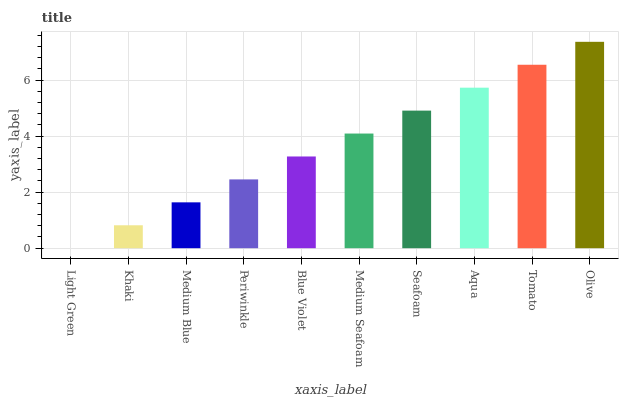Is Light Green the minimum?
Answer yes or no. Yes. Is Olive the maximum?
Answer yes or no. Yes. Is Khaki the minimum?
Answer yes or no. No. Is Khaki the maximum?
Answer yes or no. No. Is Khaki greater than Light Green?
Answer yes or no. Yes. Is Light Green less than Khaki?
Answer yes or no. Yes. Is Light Green greater than Khaki?
Answer yes or no. No. Is Khaki less than Light Green?
Answer yes or no. No. Is Medium Seafoam the high median?
Answer yes or no. Yes. Is Blue Violet the low median?
Answer yes or no. Yes. Is Khaki the high median?
Answer yes or no. No. Is Medium Blue the low median?
Answer yes or no. No. 